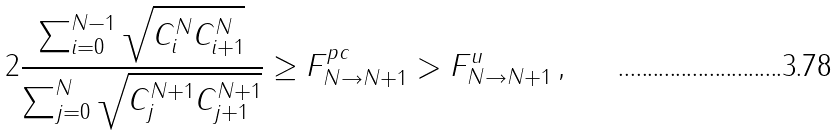<formula> <loc_0><loc_0><loc_500><loc_500>2 \frac { \sum _ { i = 0 } ^ { N - 1 } \sqrt { C _ { i } ^ { N } C _ { i + 1 } ^ { N } } } { \sum _ { j = 0 } ^ { N } \sqrt { C _ { j } ^ { N + 1 } C _ { j + 1 } ^ { N + 1 } } } \geq F _ { N \rightarrow N + 1 } ^ { p c } > F _ { N \rightarrow N + 1 } ^ { u } \, ,</formula> 